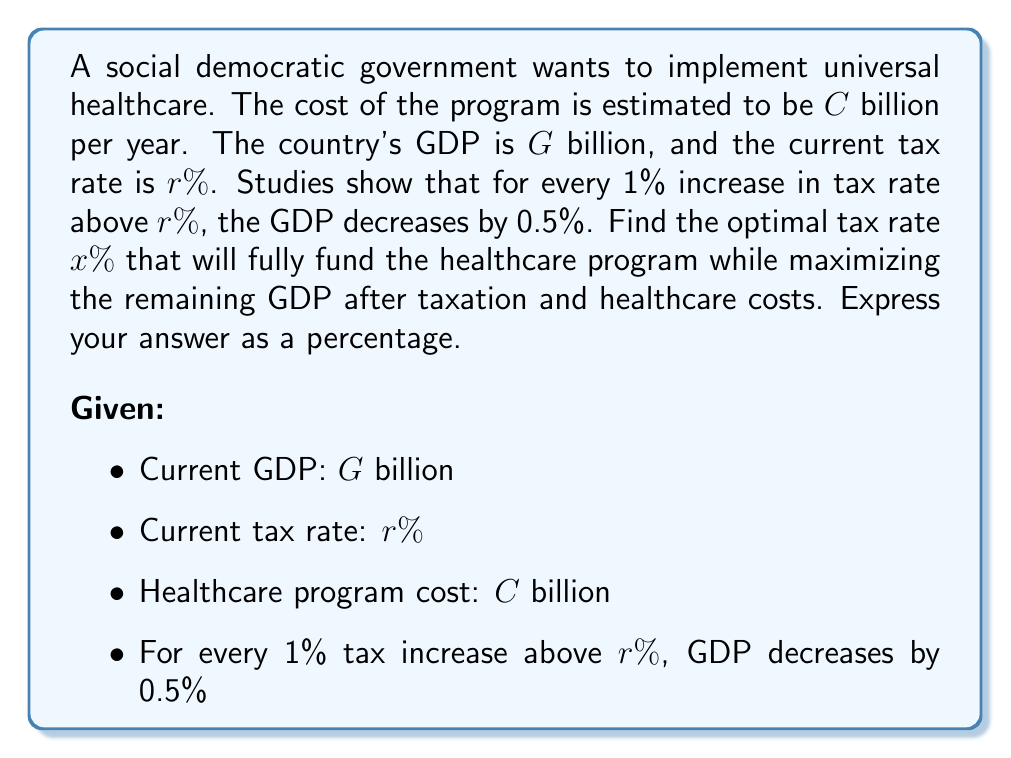Give your solution to this math problem. Let's approach this step-by-step:

1) First, we need to express the new GDP as a function of the tax increase:
   $$GDP_{new} = G \cdot (1 - 0.005(x-r))$$

2) The tax revenue at the new rate will be:
   $$Revenue = x\% \cdot GDP_{new} = 0.01x \cdot G \cdot (1 - 0.005(x-r))$$

3) For the healthcare program to be fully funded, this revenue must equal $C$:
   $$C = 0.01x \cdot G \cdot (1 - 0.005(x-r))$$

4) Expanding this equation:
   $$C = 0.01xG - 0.00005xG(x-r)$$

5) Rearranging into standard quadratic form:
   $$0.00005xG \cdot x - (0.01G + 0.00005rG) \cdot x + C = 0$$

6) This is in the form $ax^2 + bx + c = 0$, where:
   $$a = 0.00005G$$
   $$b = -(0.01G + 0.00005rG)$$
   $$c = C$$

7) We can solve this using the quadratic formula: $x = \frac{-b \pm \sqrt{b^2 - 4ac}}{2a}$

8) The optimal rate will be the smaller of the two solutions, as it will leave more GDP after taxation.

9) After solving, we need to check if this rate is higher than the current rate $r$. If not, the optimal rate is simply the rate that exactly funds the program: $x = \frac{C}{0.01G}$

10) The remaining GDP after taxation and healthcare costs is:
    $$GDP_{remaining} = GDP_{new} - Revenue - C$$
    $$= G(1 - 0.005(x-r)) - 0.01xG(1 - 0.005(x-r)) - C$$

11) To verify optimality, we should check that a small increase or decrease in the tax rate reduces this remaining GDP.
Answer: $x\% = \min(\frac{-b - \sqrt{b^2 - 4ac}}{2a}, \max(r, \frac{C}{0.01G}))\%$, where $a = 0.00005G$, $b = -(0.01G + 0.00005rG)$, $c = C$ 